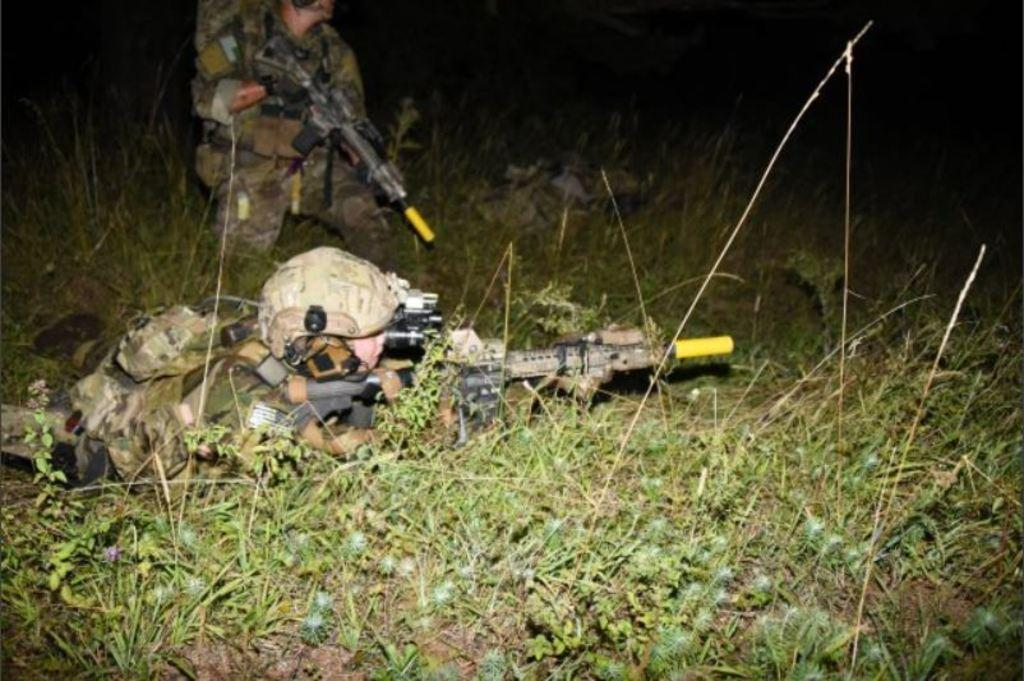What are the two people in the image holding? The two people in the image are holding guns. What is the person on the ground doing in the image? The person laying on the grass in the image is not doing any specific action. How would you describe the lighting in the image? The background of the image is dark. What type of bushes can be seen growing in the ice in the image? There is no ice or bushes present in the image. 